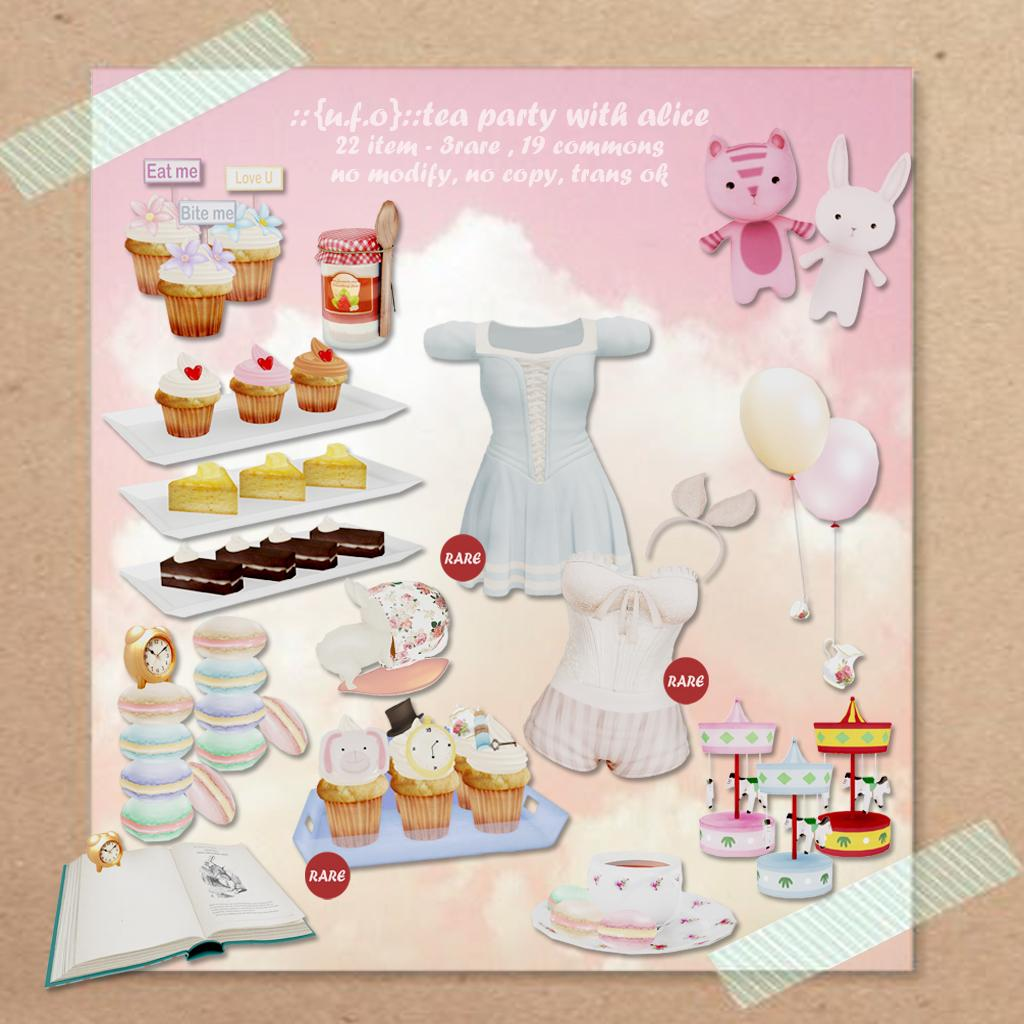What is on the wall in the image? There is a poster on the wall in the image. What types of items are depicted on the poster? The poster contains pictures of dresses, cupcakes, jars, soft toys, and a book. Is there any text on the poster? Yes, there is some text on the poster. What type of hammer is being used by the beginner in the image? There is no hammer or beginner present in the image; it features a poster with various pictures and text. How many wrenches are visible in the image? There are no wrenches visible in the image. 